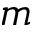<formula> <loc_0><loc_0><loc_500><loc_500>m</formula> 